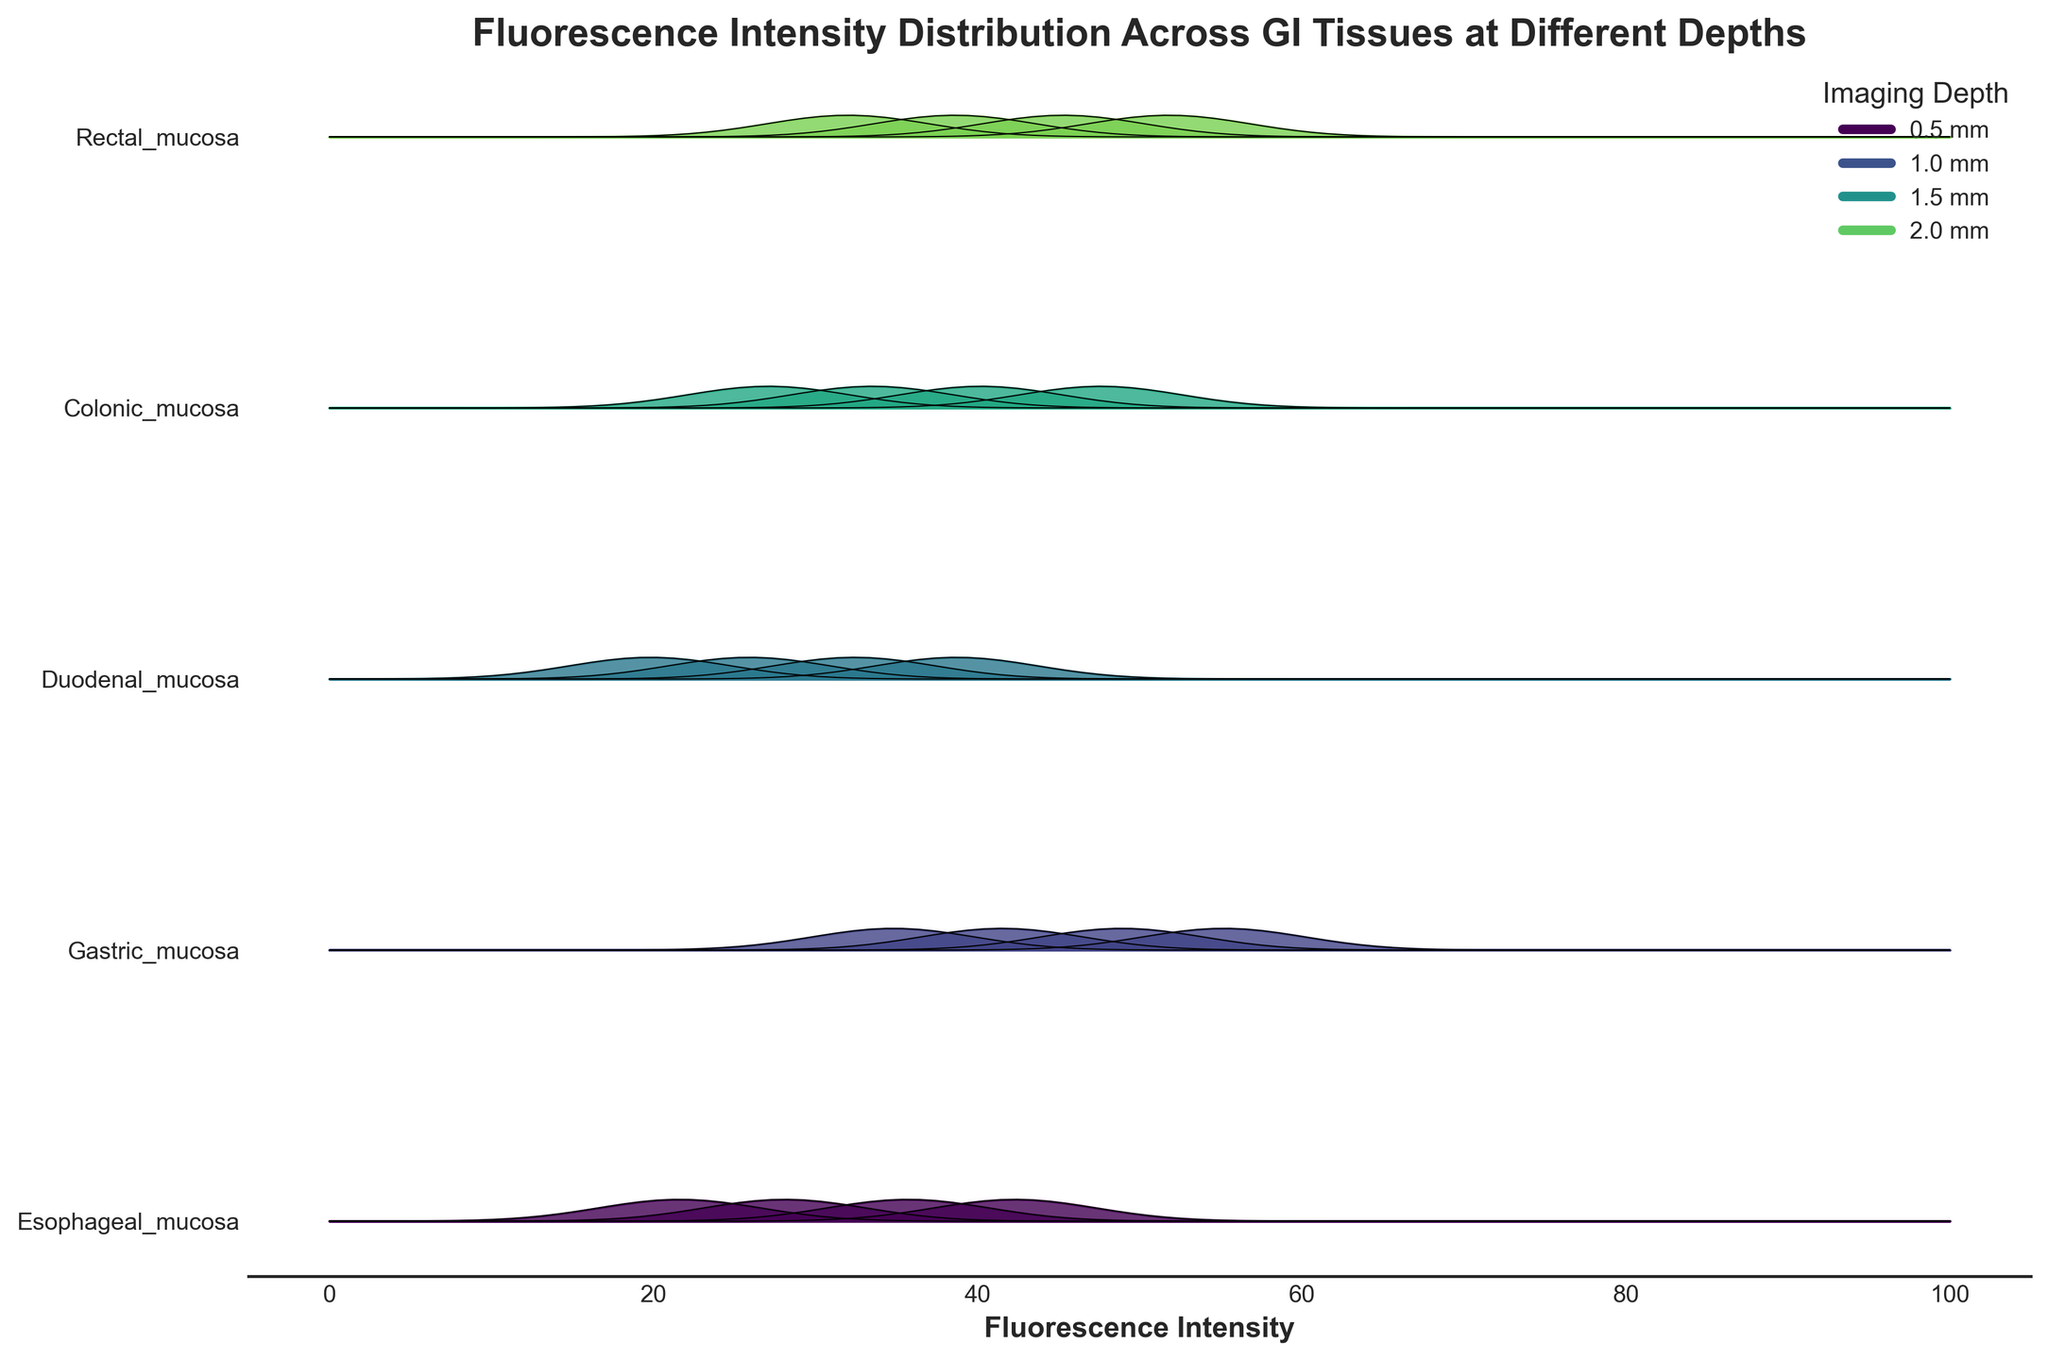What is the title of the plot? The title is usually placed at the top of the plot, providing a summary of the visualized data.
Answer: Fluorescence Intensity Distribution Across GI Tissues at Different Depths What is the x-axis labeled as? Labels on the x-axis explain what the measured variable is, which in this case can be read directly from the plot.
Answer: Fluorescence Intensity How many different gastrointestinal tissues are represented in the plot? Each unique label on the y-axis represents a different gastrointestinal tissue.
Answer: Five Which tissue has the highest fluorescence intensity at an imaging depth of 0.5 mm? By examining the ridgelines at 0.5 mm depth (the leftmost positions) and identifying the highest, you can determine this.
Answer: Gastric mucosa How do the fluorescence intensities generally change with increasing imaging depth for Esophageal mucosa? Observing the sequential ridgelines from left to right for Esophageal mucosa shows the trend or pattern of change in intensity.
Answer: They decrease Which tissue shows the highest fluorescence intensity at 1.5 mm depth? By comparing the peaks of the ridgelines corresponding to 1.5 mm for each tissue, the highest can be determined.
Answer: Gastric mucosa Between Colonic mucosa and Rectal mucosa, which tissue shows a higher intensity at a depth of 2.0 mm? Compare the peak intensity values of the ridgelines at 2.0 mm depth for both tissues.
Answer: Rectal mucosa What are the maximum and minimum fluorescence intensity values observed in the plot? By examining the range of the x-axis for the plotted data, the maximum and minimum values can be identified.
Answer: Max: 55.2, Min: 19.8 Which tissue shows the most significant decrease in fluorescence intensity from 0.5 mm to 2.0 mm? Calculate the difference in fluorescence intensity between 0.5 mm and 2.0 mm for each tissue and compare the values. The highest decrease represents the most significant drop.
Answer: Esophageal mucosa What is the average fluorescence intensity at a depth of 1.0 mm across all tissues? Sum the fluorescence intensities for all tissues at 1.0 mm depth and divide by the number of tissues.
Answer: (35.7 + 48.9 + 32.4 + 40.2 + 45.3) / 5 = 40.5 